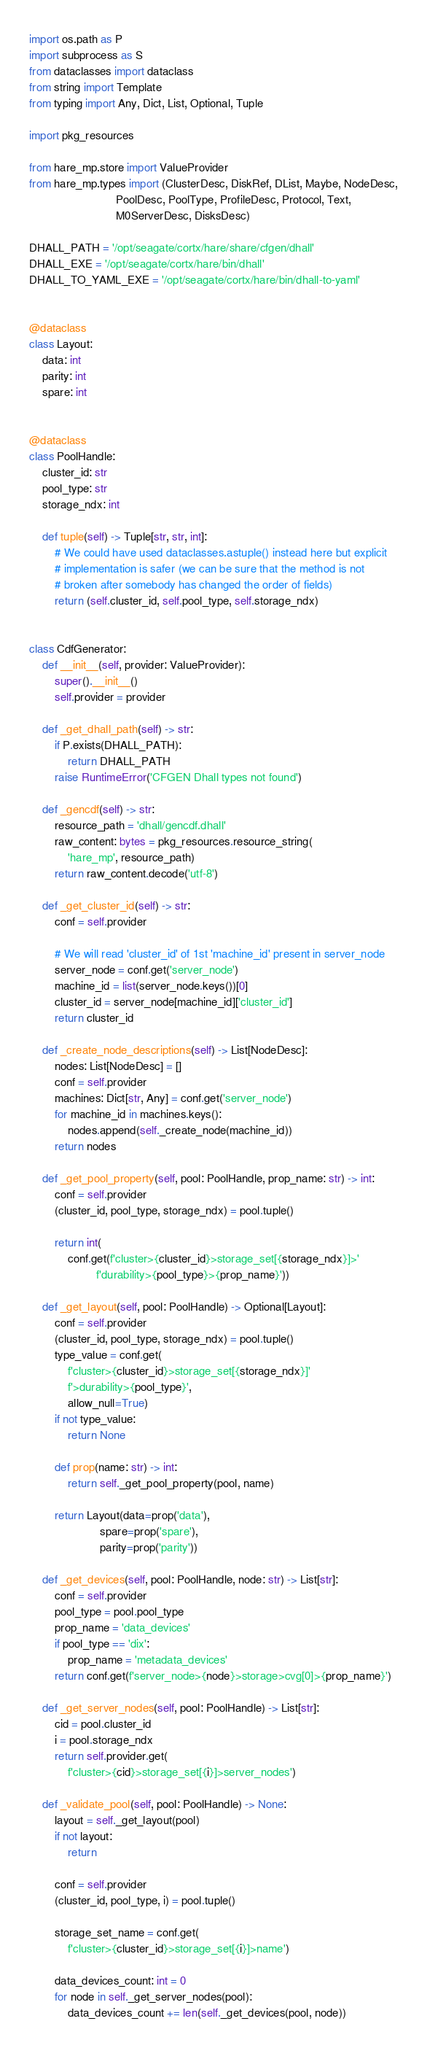<code> <loc_0><loc_0><loc_500><loc_500><_Python_>import os.path as P
import subprocess as S
from dataclasses import dataclass
from string import Template
from typing import Any, Dict, List, Optional, Tuple

import pkg_resources

from hare_mp.store import ValueProvider
from hare_mp.types import (ClusterDesc, DiskRef, DList, Maybe, NodeDesc,
                           PoolDesc, PoolType, ProfileDesc, Protocol, Text,
                           M0ServerDesc, DisksDesc)

DHALL_PATH = '/opt/seagate/cortx/hare/share/cfgen/dhall'
DHALL_EXE = '/opt/seagate/cortx/hare/bin/dhall'
DHALL_TO_YAML_EXE = '/opt/seagate/cortx/hare/bin/dhall-to-yaml'


@dataclass
class Layout:
    data: int
    parity: int
    spare: int


@dataclass
class PoolHandle:
    cluster_id: str
    pool_type: str
    storage_ndx: int

    def tuple(self) -> Tuple[str, str, int]:
        # We could have used dataclasses.astuple() instead here but explicit
        # implementation is safer (we can be sure that the method is not
        # broken after somebody has changed the order of fields)
        return (self.cluster_id, self.pool_type, self.storage_ndx)


class CdfGenerator:
    def __init__(self, provider: ValueProvider):
        super().__init__()
        self.provider = provider

    def _get_dhall_path(self) -> str:
        if P.exists(DHALL_PATH):
            return DHALL_PATH
        raise RuntimeError('CFGEN Dhall types not found')

    def _gencdf(self) -> str:
        resource_path = 'dhall/gencdf.dhall'
        raw_content: bytes = pkg_resources.resource_string(
            'hare_mp', resource_path)
        return raw_content.decode('utf-8')

    def _get_cluster_id(self) -> str:
        conf = self.provider

        # We will read 'cluster_id' of 1st 'machine_id' present in server_node
        server_node = conf.get('server_node')
        machine_id = list(server_node.keys())[0]
        cluster_id = server_node[machine_id]['cluster_id']
        return cluster_id

    def _create_node_descriptions(self) -> List[NodeDesc]:
        nodes: List[NodeDesc] = []
        conf = self.provider
        machines: Dict[str, Any] = conf.get('server_node')
        for machine_id in machines.keys():
            nodes.append(self._create_node(machine_id))
        return nodes

    def _get_pool_property(self, pool: PoolHandle, prop_name: str) -> int:
        conf = self.provider
        (cluster_id, pool_type, storage_ndx) = pool.tuple()

        return int(
            conf.get(f'cluster>{cluster_id}>storage_set[{storage_ndx}]>'
                     f'durability>{pool_type}>{prop_name}'))

    def _get_layout(self, pool: PoolHandle) -> Optional[Layout]:
        conf = self.provider
        (cluster_id, pool_type, storage_ndx) = pool.tuple()
        type_value = conf.get(
            f'cluster>{cluster_id}>storage_set[{storage_ndx}]'
            f'>durability>{pool_type}',
            allow_null=True)
        if not type_value:
            return None

        def prop(name: str) -> int:
            return self._get_pool_property(pool, name)

        return Layout(data=prop('data'),
                      spare=prop('spare'),
                      parity=prop('parity'))

    def _get_devices(self, pool: PoolHandle, node: str) -> List[str]:
        conf = self.provider
        pool_type = pool.pool_type
        prop_name = 'data_devices'
        if pool_type == 'dix':
            prop_name = 'metadata_devices'
        return conf.get(f'server_node>{node}>storage>cvg[0]>{prop_name}')

    def _get_server_nodes(self, pool: PoolHandle) -> List[str]:
        cid = pool.cluster_id
        i = pool.storage_ndx
        return self.provider.get(
            f'cluster>{cid}>storage_set[{i}]>server_nodes')

    def _validate_pool(self, pool: PoolHandle) -> None:
        layout = self._get_layout(pool)
        if not layout:
            return

        conf = self.provider
        (cluster_id, pool_type, i) = pool.tuple()

        storage_set_name = conf.get(
            f'cluster>{cluster_id}>storage_set[{i}]>name')

        data_devices_count: int = 0
        for node in self._get_server_nodes(pool):
            data_devices_count += len(self._get_devices(pool, node))
</code> 